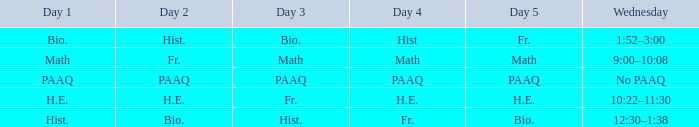What is the day 3 when day 4 is fr.? Hist. 